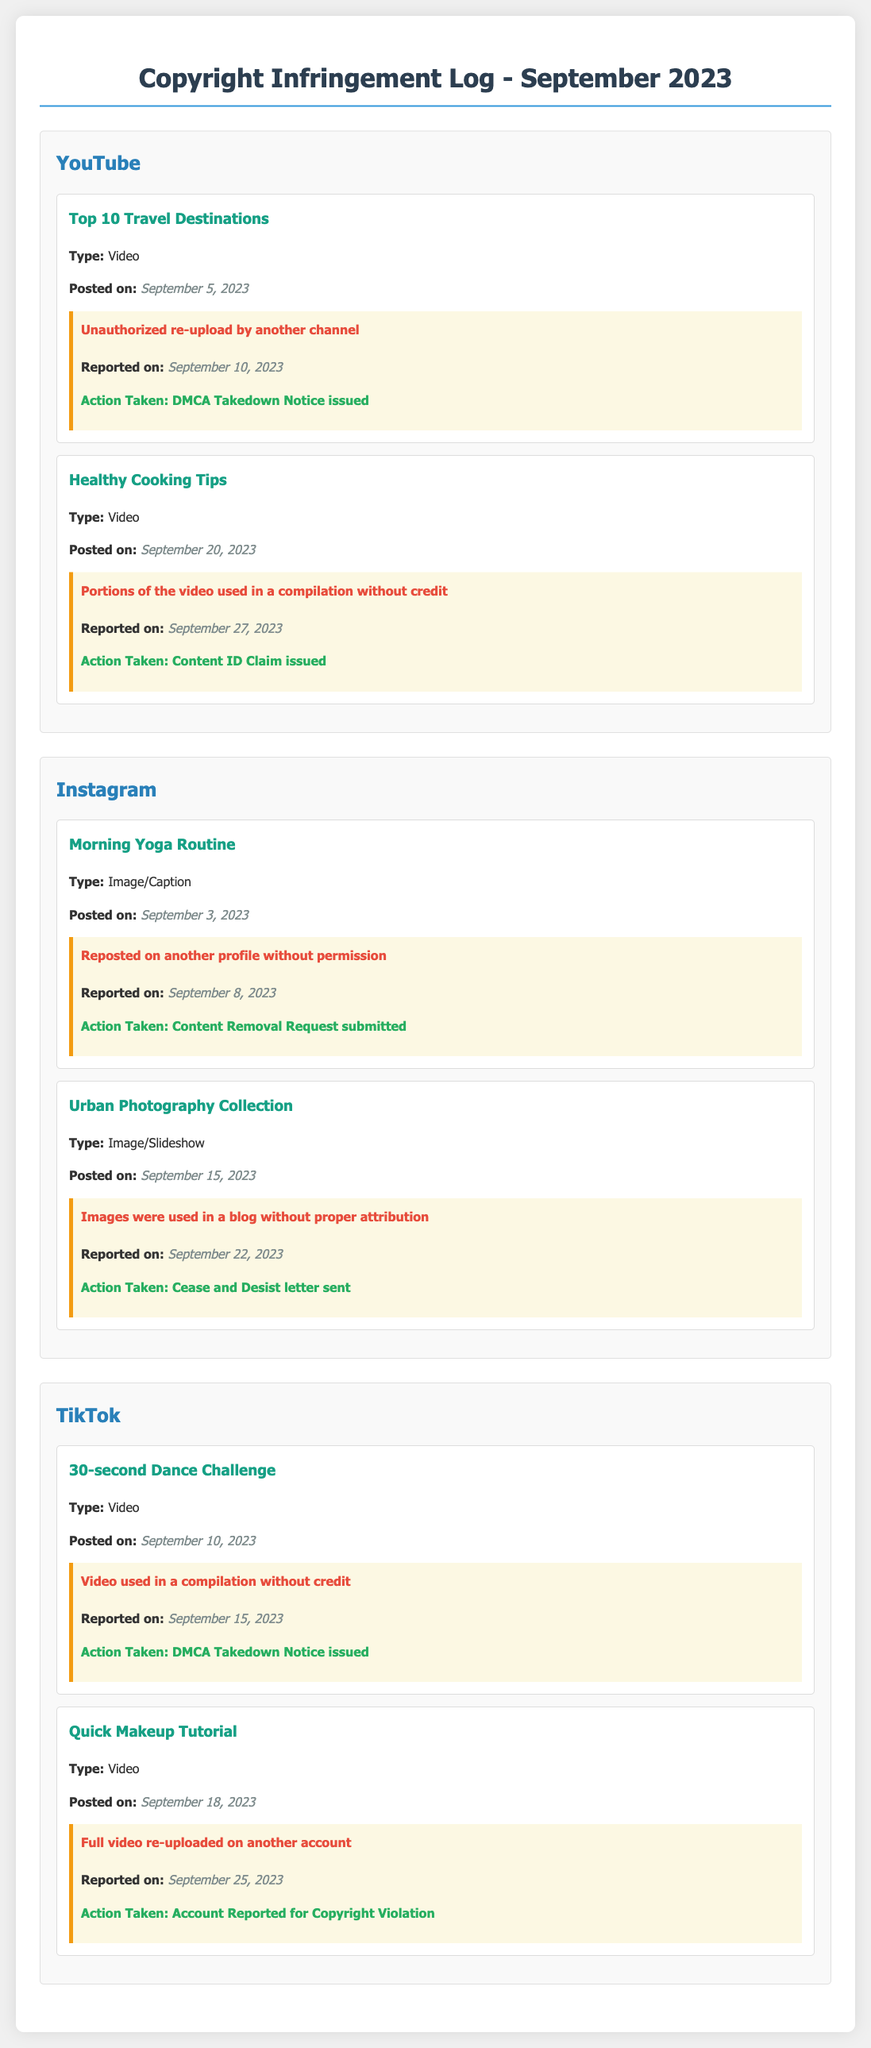What type of content was posted on September 5, 2023? The content titled "Top 10 Travel Destinations" is a video posted on that date.
Answer: Video How many instances of copyright infringement were reported in September 2023? There are a total of five instances of identified misuse or copyright infringement reported in the document.
Answer: 5 What action was taken against the misuse of the "Quick Makeup Tutorial"? The action taken was reporting the account for copyright violation due to the full video re-upload.
Answer: Account Reported for Copyright Violation Which platform had a misuse report submitted for a photo posted on September 3, 2023? The misuse report was related to the "Morning Yoga Routine" on Instagram for unauthorized reposting.
Answer: Instagram On what date was the "Healthy Cooking Tips" video posted? The video "Healthy Cooking Tips" was posted on September 20, 2023.
Answer: September 20, 2023 What was the type of content for the "Urban Photography Collection"? The content type is an image/slideshow.
Answer: Image/Slideshow How many videos were reported for unauthorized re-uploads? Two videos were reported for unauthorized re-uploads.
Answer: 2 What was the date when the misuse of the "30-second Dance Challenge" was reported? The report for this misuse was made on September 15, 2023.
Answer: September 15, 2023 What happened on September 22, 2023, regarding the Urban Photography images? A report was made concerning the images being used without proper attribution.
Answer: Reported for misuse 